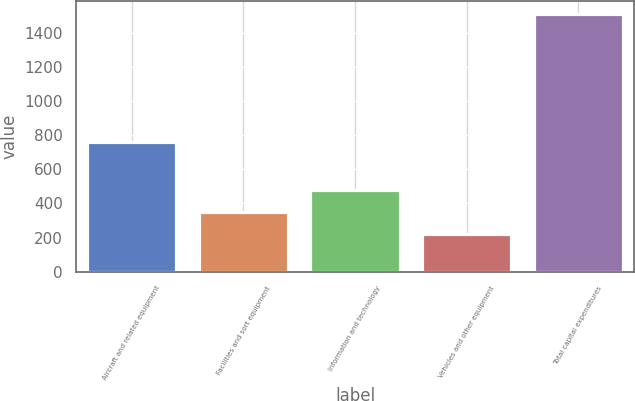<chart> <loc_0><loc_0><loc_500><loc_500><bar_chart><fcel>Aircraft and related equipment<fcel>Facilities and sort equipment<fcel>Information and technology<fcel>Vehicles and other equipment<fcel>Total capital expenditures<nl><fcel>762<fcel>350.9<fcel>479.8<fcel>222<fcel>1511<nl></chart> 